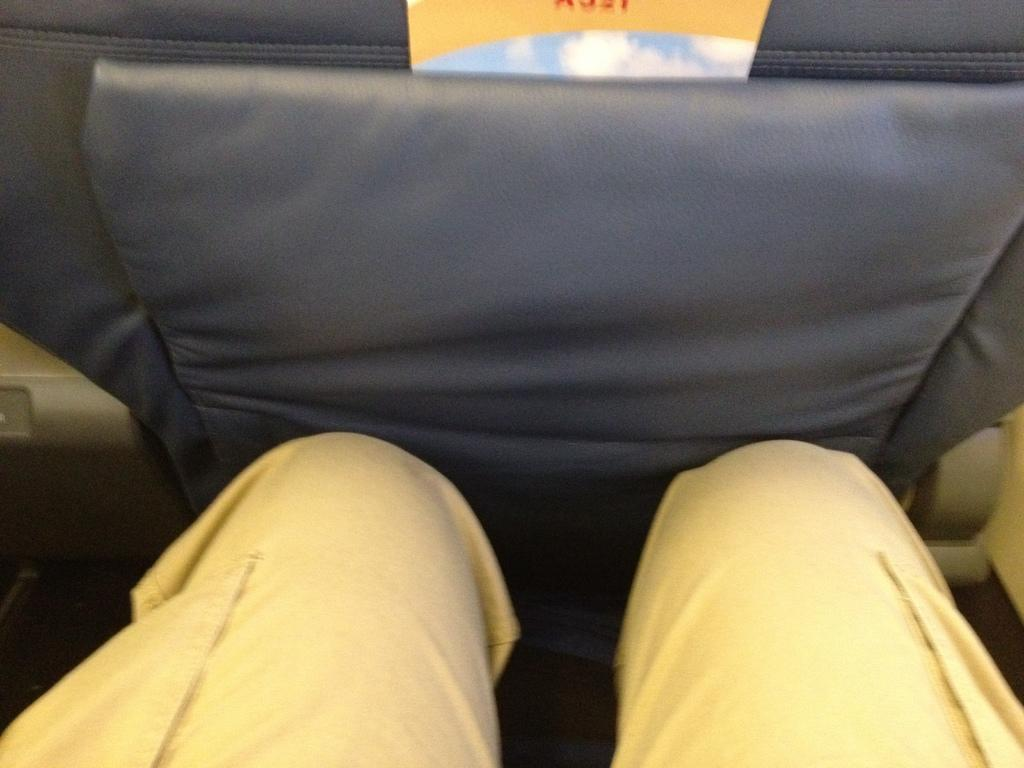What type of vehicle is shown in the image? The image shows a back view of a seat in a car. Can you describe the person in the image? The legs of a person are visible in the image. What type of skin condition can be seen on the person's legs in the image? There is no indication of a skin condition on the person's legs in the image. What type of protest is taking place in the image? There is no protest visible in the image; it only shows a back view of a seat in a car and the legs of a person. 